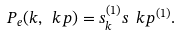<formula> <loc_0><loc_0><loc_500><loc_500>P _ { e } ( k , \ k p ) = s _ { k } ^ { ( 1 ) } s _ { \ } k p ^ { ( 1 ) } .</formula> 